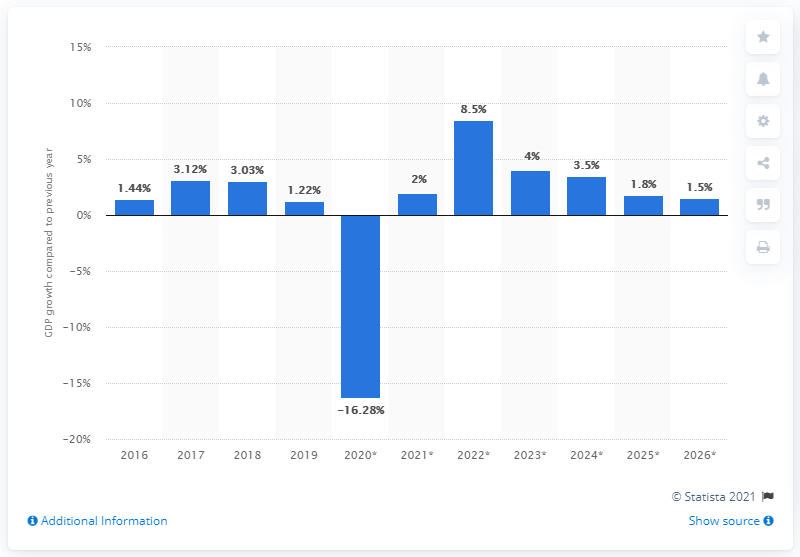Outline some significant characteristics in this image. The real gross domestic product of the Bahamas grew by 1.22% in 2019. 